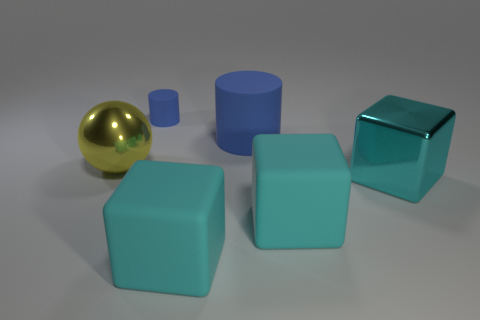Are there any blue things of the same size as the yellow metallic ball?
Make the answer very short. Yes. There is a cyan rubber cube that is left of the large object that is behind the yellow ball; is there a large thing that is right of it?
Your answer should be compact. Yes. There is a small rubber object; is it the same color as the matte cylinder that is on the right side of the tiny blue matte cylinder?
Keep it short and to the point. Yes. There is a large blue cylinder that is behind the metallic thing that is to the right of the large metallic thing that is behind the metallic cube; what is it made of?
Make the answer very short. Rubber. There is a blue matte thing that is in front of the small blue thing; what shape is it?
Ensure brevity in your answer.  Cylinder. The cyan cube that is the same material as the large yellow sphere is what size?
Make the answer very short. Large. What number of large cyan rubber objects are the same shape as the small blue thing?
Provide a short and direct response. 0. There is a cylinder in front of the small blue matte cylinder; is it the same color as the tiny object?
Keep it short and to the point. Yes. There is a matte cylinder in front of the blue rubber cylinder that is behind the big blue rubber cylinder; how many metal spheres are to the right of it?
Keep it short and to the point. 0. What number of big objects are behind the yellow metal sphere and in front of the cyan shiny object?
Offer a terse response. 0. 